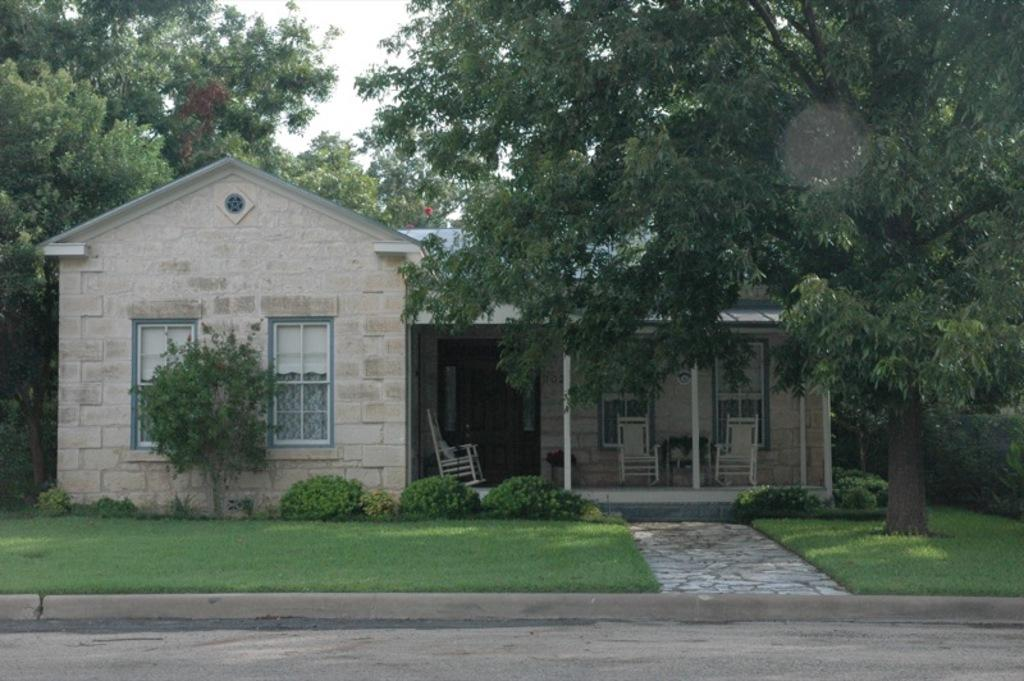What is located in the center of the picture? In the center of the picture, there are plants, a house, chairs, windows, and trees. Can you describe the foreground of the picture? The foreground of the picture includes a road and grass. What type of vegetation can be seen in the picture? In addition to the plants and trees in the center, there is grass in the foreground. How many fingers can be seen touching the leaves of the plants in the picture? There are no fingers visible in the picture; it only shows plants, a house, chairs, windows, trees, a road, and grass. What mark can be seen on the tongue of the person in the picture? There is no person or tongue present in the picture. 